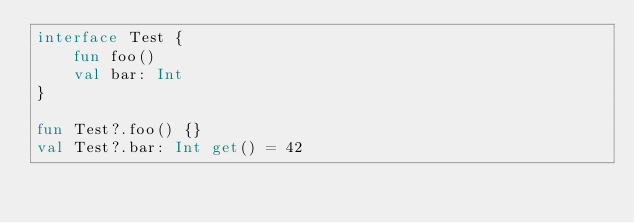<code> <loc_0><loc_0><loc_500><loc_500><_Kotlin_>interface Test {
    fun foo()
    val bar: Int
}

fun Test?.foo() {}
val Test?.bar: Int get() = 42</code> 